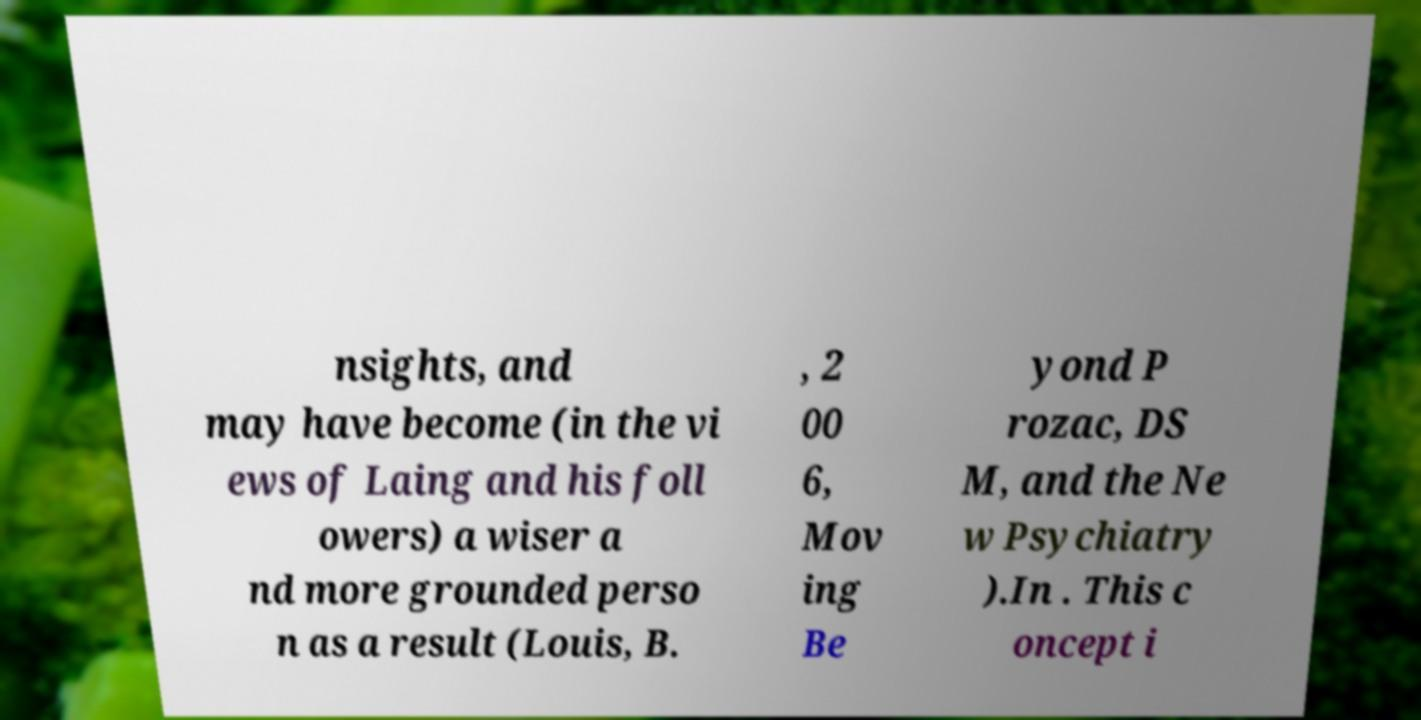What messages or text are displayed in this image? I need them in a readable, typed format. nsights, and may have become (in the vi ews of Laing and his foll owers) a wiser a nd more grounded perso n as a result (Louis, B. , 2 00 6, Mov ing Be yond P rozac, DS M, and the Ne w Psychiatry ).In . This c oncept i 